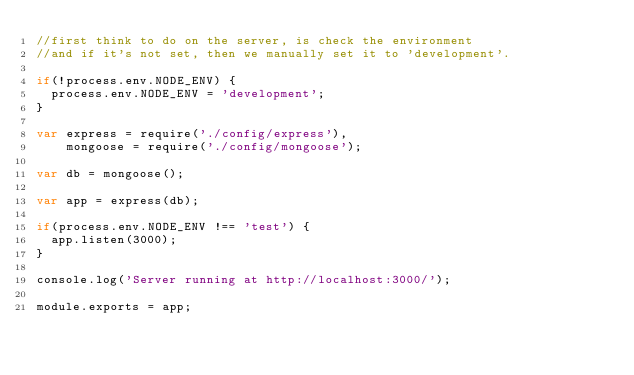Convert code to text. <code><loc_0><loc_0><loc_500><loc_500><_JavaScript_>//first think to do on the server, is check the environment
//and if it's not set, then we manually set it to 'development'.

if(!process.env.NODE_ENV) {
  process.env.NODE_ENV = 'development';
}

var express = require('./config/express'),
    mongoose = require('./config/mongoose');

var db = mongoose();

var app = express(db);

if(process.env.NODE_ENV !== 'test') {
  app.listen(3000);
}

console.log('Server running at http://localhost:3000/');

module.exports = app;
</code> 